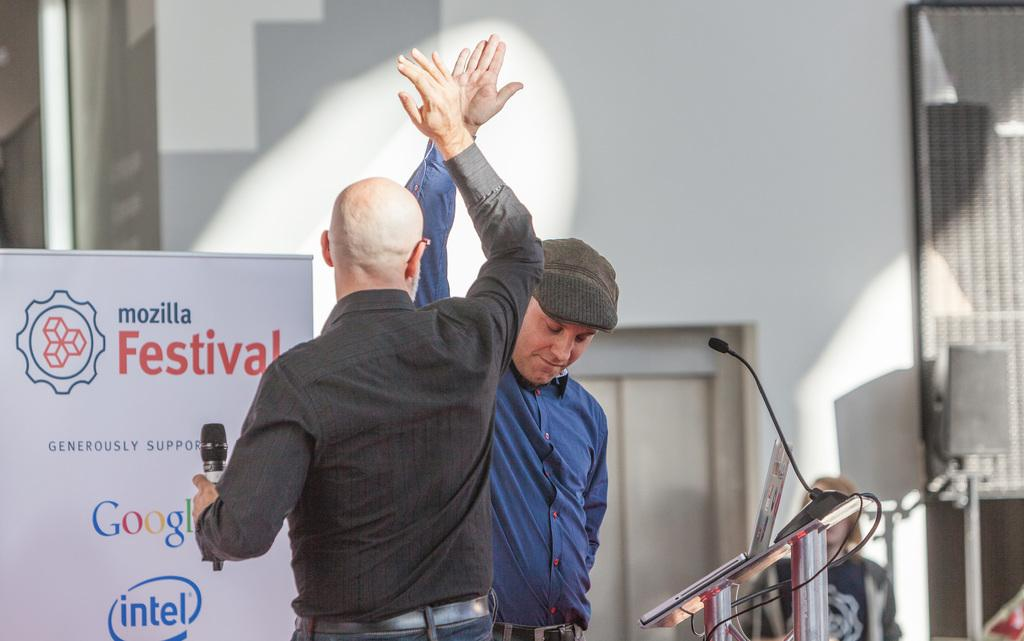How many people are in the image? There are two men in the image. What is one of the men holding? One of the men is holding a microphone. What can be seen in the image besides the men and microphone? There is a banner, a podium, and a wall with a speaker in the background of the image. What type of clam is sitting on the podium in the image? There is no clam present in the image; the podium is empty. What type of wire is used to connect the microphone to the speaker in the image? There is no wire visible in the image, so it is not possible to determine what type of wire might be used. 